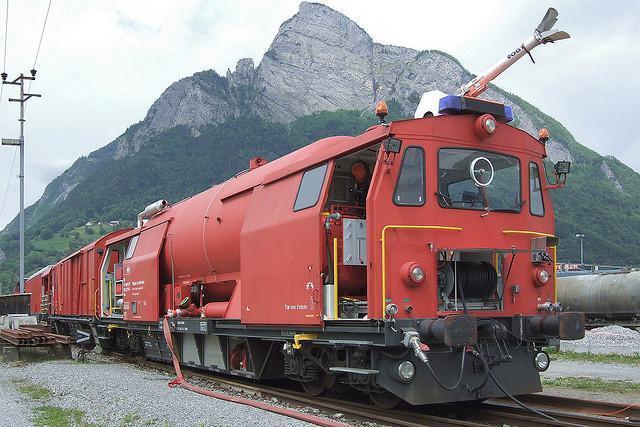How many trains are there?
Give a very brief answer. 2. How many clocks are shown?
Give a very brief answer. 0. 